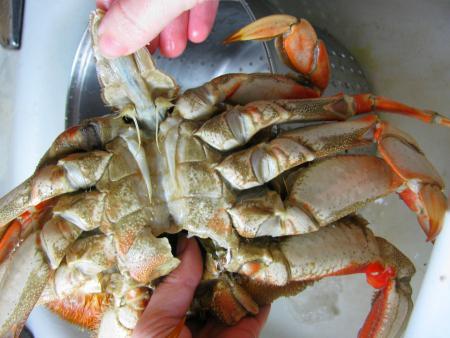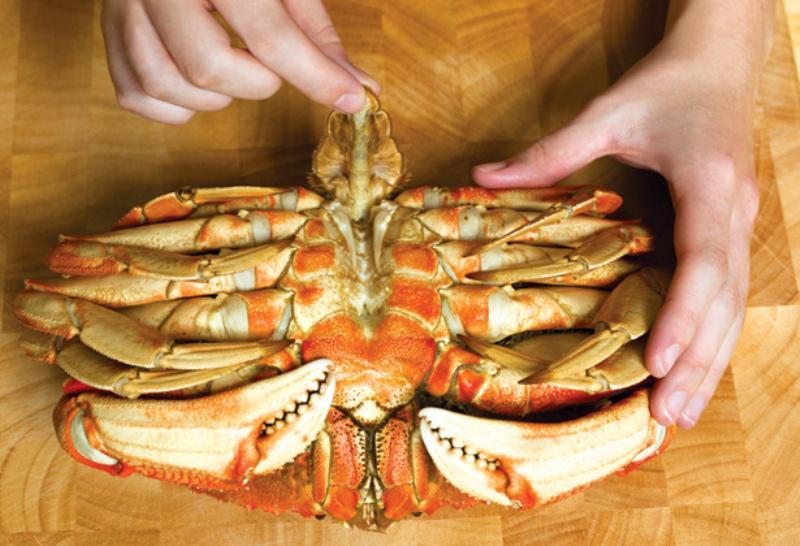The first image is the image on the left, the second image is the image on the right. Analyze the images presented: Is the assertion "there are three crabs in the image pair" valid? Answer yes or no. No. The first image is the image on the left, the second image is the image on the right. Evaluate the accuracy of this statement regarding the images: "The right image includes at least one hand grasping a crab with its shell removed, while the left image shows a view of a crab with no hands present.". Is it true? Answer yes or no. No. 